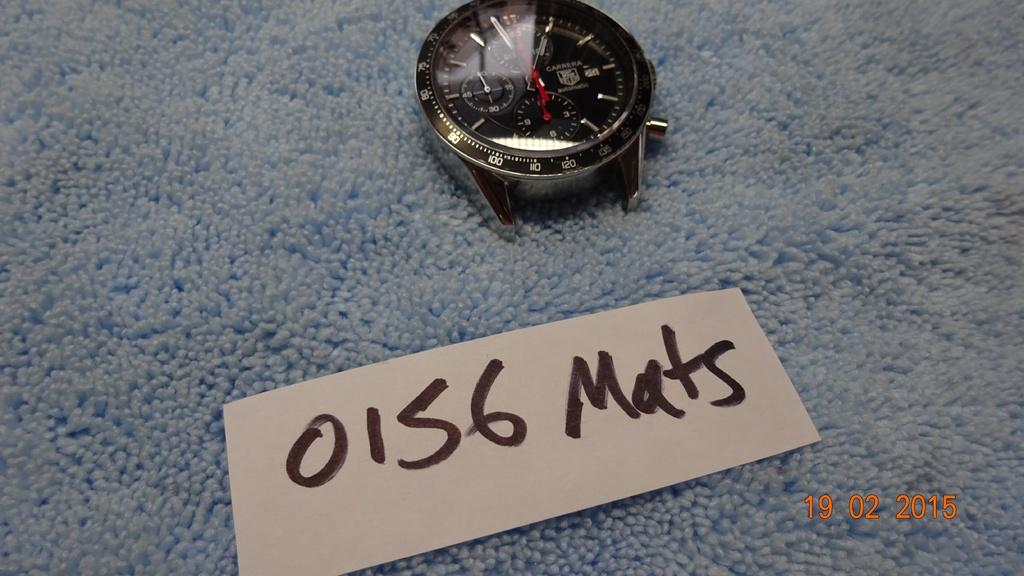<image>
Offer a succinct explanation of the picture presented. A piece of a watch with a 0156 Mats label. 